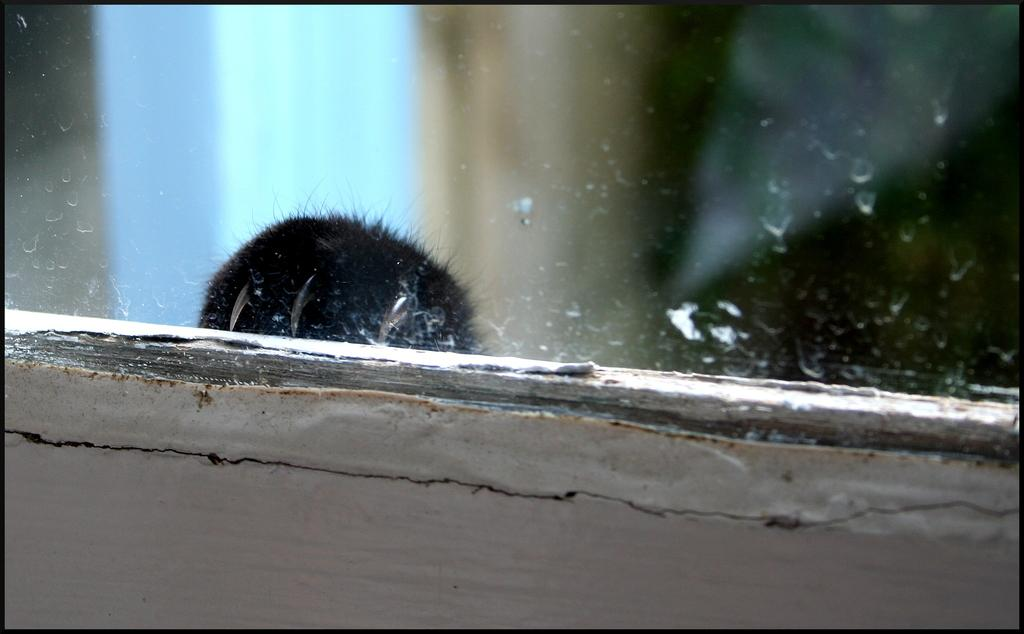What type of object is present in the image? There is a window mirror in the image. What type of amusement can be seen in the image? There is no amusement present in the image; it features a window mirror. How many stars are visible in the image? There are no stars visible in the image; it features a window mirror. 